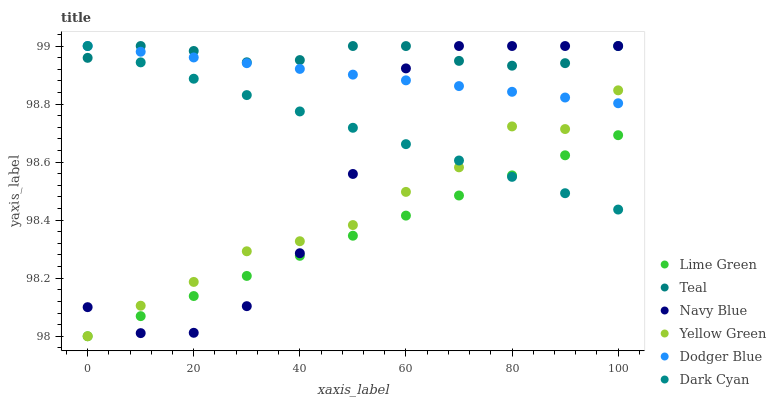Does Lime Green have the minimum area under the curve?
Answer yes or no. Yes. Does Teal have the maximum area under the curve?
Answer yes or no. Yes. Does Navy Blue have the minimum area under the curve?
Answer yes or no. No. Does Navy Blue have the maximum area under the curve?
Answer yes or no. No. Is Dark Cyan the smoothest?
Answer yes or no. Yes. Is Navy Blue the roughest?
Answer yes or no. Yes. Is Dodger Blue the smoothest?
Answer yes or no. No. Is Dodger Blue the roughest?
Answer yes or no. No. Does Yellow Green have the lowest value?
Answer yes or no. Yes. Does Navy Blue have the lowest value?
Answer yes or no. No. Does Dark Cyan have the highest value?
Answer yes or no. Yes. Does Lime Green have the highest value?
Answer yes or no. No. Is Lime Green less than Dodger Blue?
Answer yes or no. Yes. Is Teal greater than Yellow Green?
Answer yes or no. Yes. Does Teal intersect Dark Cyan?
Answer yes or no. Yes. Is Teal less than Dark Cyan?
Answer yes or no. No. Is Teal greater than Dark Cyan?
Answer yes or no. No. Does Lime Green intersect Dodger Blue?
Answer yes or no. No. 